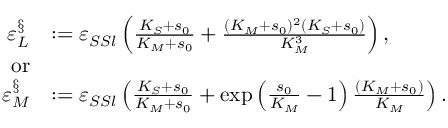Convert formula to latex. <formula><loc_0><loc_0><loc_500><loc_500>\begin{array} { r l } { \varepsilon _ { L } ^ { \S } } & { \colon = \varepsilon _ { S S l } \left ( \frac { K _ { S } + s _ { 0 } } { K _ { M } + s _ { 0 } } + \frac { ( K _ { M } + s _ { 0 } ) ^ { 2 } ( K _ { S } + s _ { 0 } ) } { K _ { M } ^ { 3 } } \right ) , } \\ { o r } \\ { \varepsilon _ { M } ^ { \S } } & { \colon = \varepsilon _ { S S l } \left ( \frac { K _ { S } + s _ { 0 } } { K _ { M } + s _ { 0 } } + \exp \left ( \frac { s _ { 0 } } { K _ { M } } - 1 \right ) \frac { ( K _ { M } + s _ { 0 } ) } { K _ { M } } \right ) . } \end{array}</formula> 